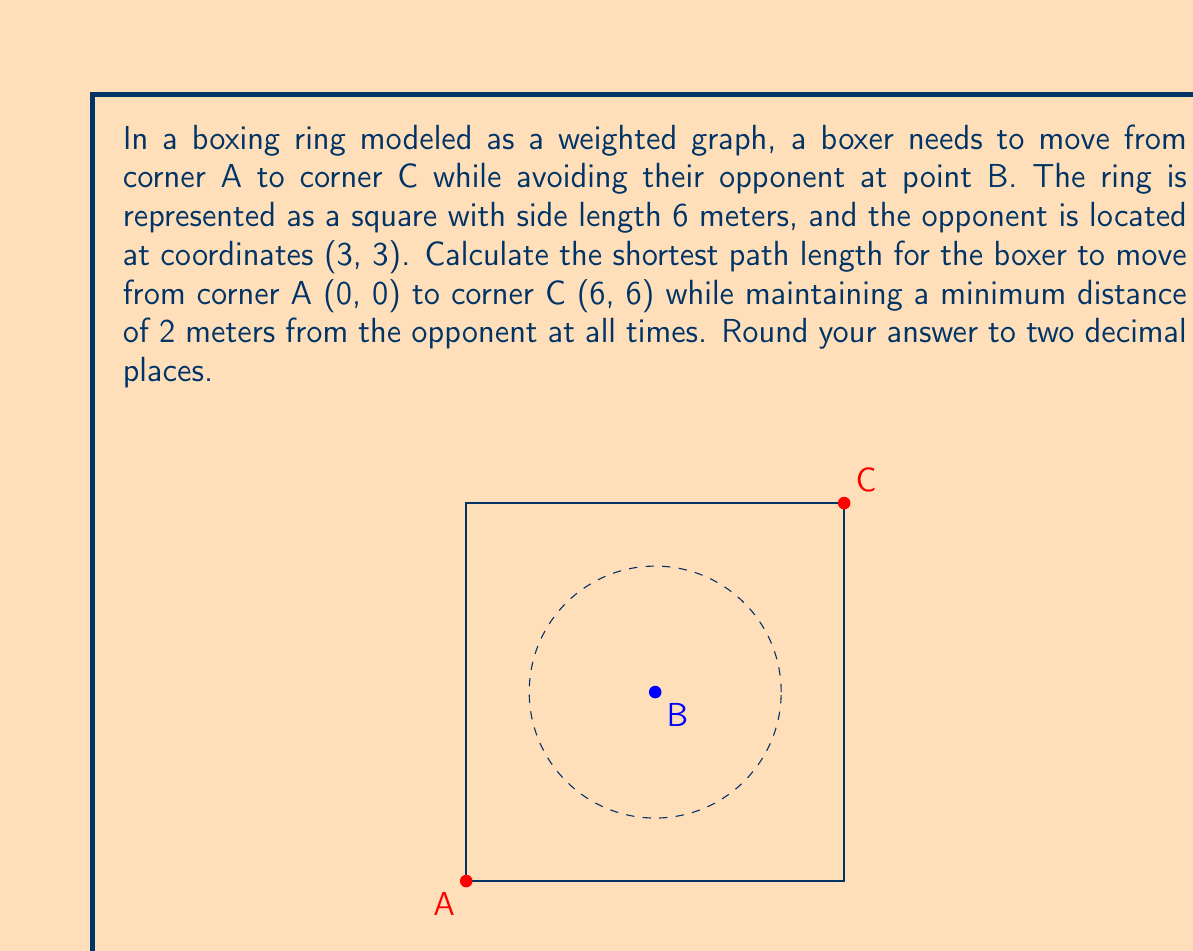Show me your answer to this math problem. To solve this problem, we need to apply concepts from graph theory and geometry. Let's break it down step-by-step:

1) First, we need to understand that the shortest path will be tangent to the circle representing the minimum distance from the opponent.

2) The equation of the circle with center (3, 3) and radius 2 is:
   $$(x-3)^2 + (y-3)^2 = 4$$

3) The shortest path will consist of two line segments: from A to a point P on the circle, and from P to C.

4) To find point P, we can use the fact that the line AP will be perpendicular to the radius BP. The same applies to PC and BP.

5) The equation of line AP can be written as:
   $$y = mx$$
   where m is the slope.

6) The equation of line PC can be written as:
   $$y - 6 = m'(x - 6)$$
   where m' is the slope.

7) The slopes m and m' are related: $m' = -\frac{1}{m}$ (perpendicular lines)

8) Substituting the circle equation and line equations, we get a system of equations:
   $$(x-3)^2 + (mx-3)^2 = 4$$
   $$x^2 + mx^2 - 6x - 6mx + 18 = 4$$
   $$(1+m^2)x^2 - (6+6m)x + 14 = 0$$

9) This is a quadratic equation in x. We want the solution where x is between 0 and 3.

10) Solving this equation numerically (as an exact solution is complex), we get:
    $$x \approx 1.1716, y \approx 1.1716$$

11) The total path length is then:
    $$\sqrt{1.1716^2 + 1.1716^2} + \sqrt{(6-1.1716)^2 + (6-1.1716)^2}$$

12) Calculating this gives us approximately 8.4853 meters.
Answer: $8.49$ meters 